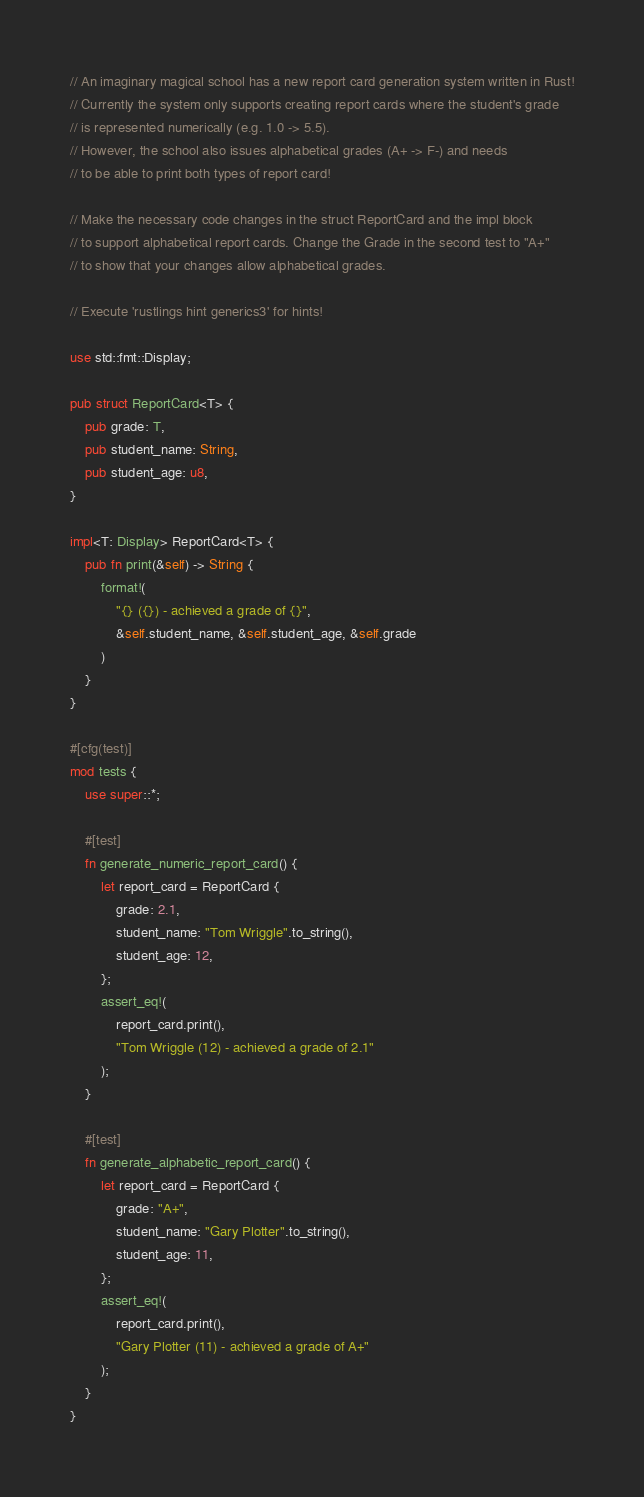Convert code to text. <code><loc_0><loc_0><loc_500><loc_500><_Rust_>// An imaginary magical school has a new report card generation system written in Rust!
// Currently the system only supports creating report cards where the student's grade
// is represented numerically (e.g. 1.0 -> 5.5).
// However, the school also issues alphabetical grades (A+ -> F-) and needs
// to be able to print both types of report card!

// Make the necessary code changes in the struct ReportCard and the impl block
// to support alphabetical report cards. Change the Grade in the second test to "A+"
// to show that your changes allow alphabetical grades.

// Execute 'rustlings hint generics3' for hints!

use std::fmt::Display;

pub struct ReportCard<T> {
    pub grade: T,
    pub student_name: String,
    pub student_age: u8,
}

impl<T: Display> ReportCard<T> {
    pub fn print(&self) -> String {
        format!(
            "{} ({}) - achieved a grade of {}",
            &self.student_name, &self.student_age, &self.grade
        )
    }
}

#[cfg(test)]
mod tests {
    use super::*;

    #[test]
    fn generate_numeric_report_card() {
        let report_card = ReportCard {
            grade: 2.1,
            student_name: "Tom Wriggle".to_string(),
            student_age: 12,
        };
        assert_eq!(
            report_card.print(),
            "Tom Wriggle (12) - achieved a grade of 2.1"
        );
    }

    #[test]
    fn generate_alphabetic_report_card() {
        let report_card = ReportCard {
            grade: "A+",
            student_name: "Gary Plotter".to_string(),
            student_age: 11,
        };
        assert_eq!(
            report_card.print(),
            "Gary Plotter (11) - achieved a grade of A+"
        );
    }
}
</code> 